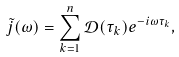Convert formula to latex. <formula><loc_0><loc_0><loc_500><loc_500>\tilde { j } ( \omega ) = \sum _ { k = 1 } ^ { n } \mathcal { D } ( \tau _ { k } ) e ^ { - i \omega \tau _ { k } } ,</formula> 